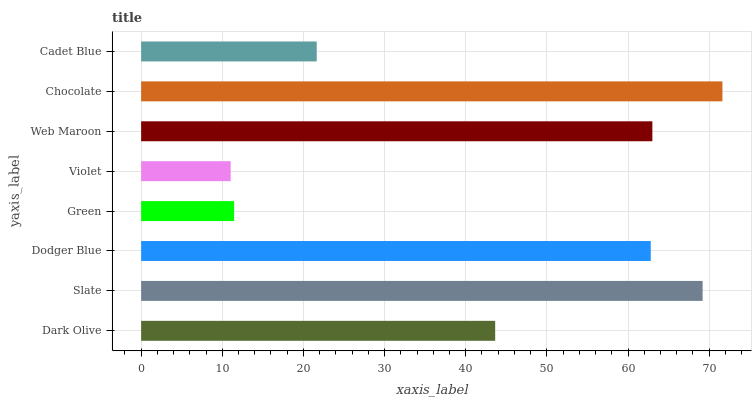Is Violet the minimum?
Answer yes or no. Yes. Is Chocolate the maximum?
Answer yes or no. Yes. Is Slate the minimum?
Answer yes or no. No. Is Slate the maximum?
Answer yes or no. No. Is Slate greater than Dark Olive?
Answer yes or no. Yes. Is Dark Olive less than Slate?
Answer yes or no. Yes. Is Dark Olive greater than Slate?
Answer yes or no. No. Is Slate less than Dark Olive?
Answer yes or no. No. Is Dodger Blue the high median?
Answer yes or no. Yes. Is Dark Olive the low median?
Answer yes or no. Yes. Is Green the high median?
Answer yes or no. No. Is Dodger Blue the low median?
Answer yes or no. No. 